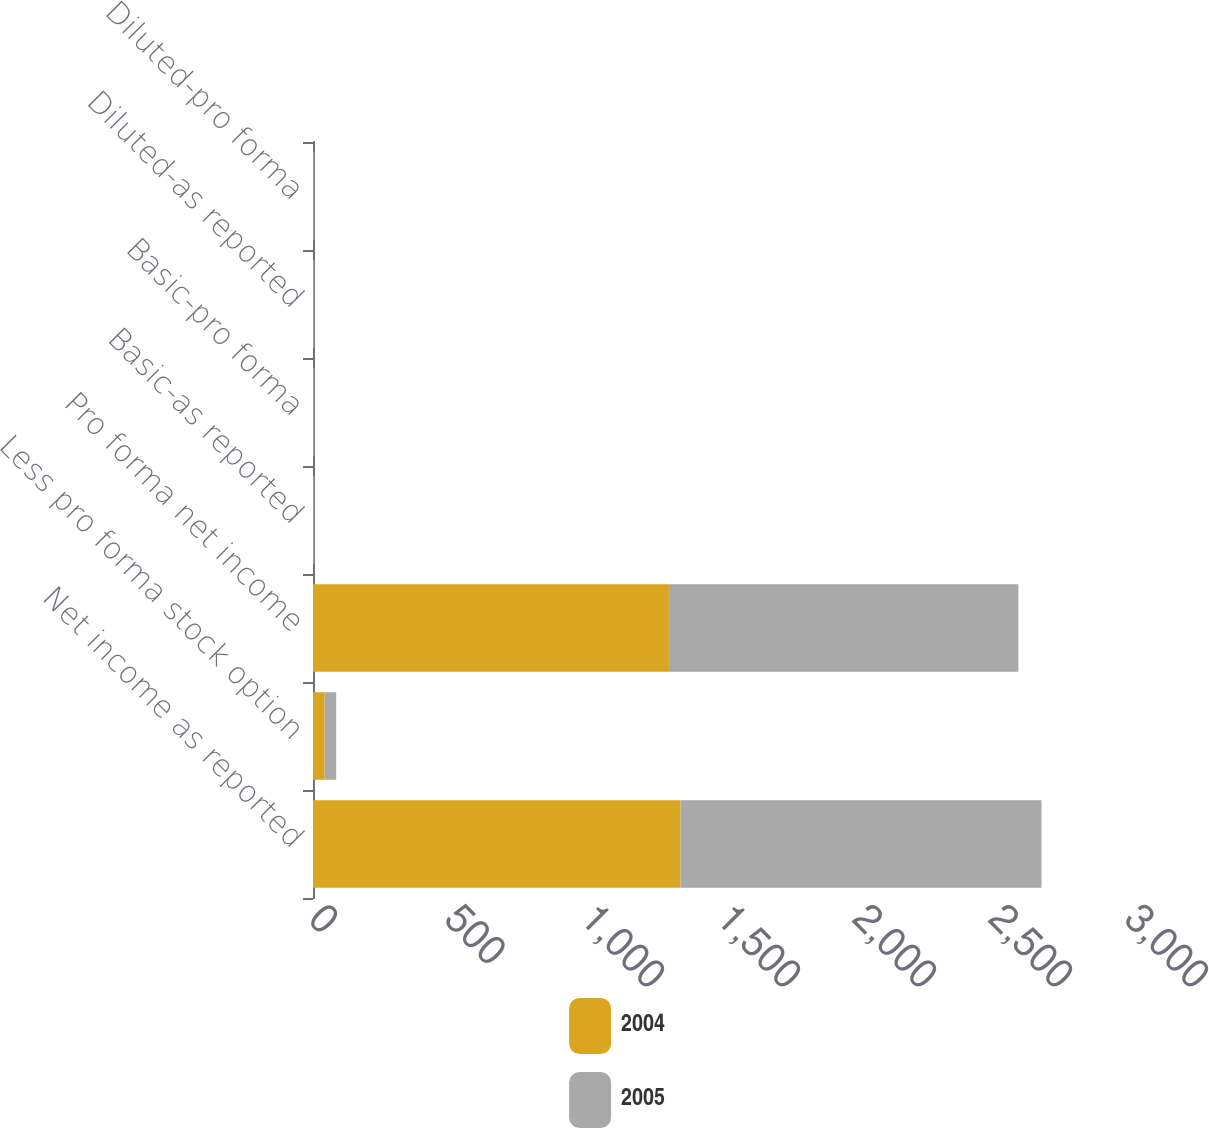Convert chart. <chart><loc_0><loc_0><loc_500><loc_500><stacked_bar_chart><ecel><fcel>Net income as reported<fcel>Less pro forma stock option<fcel>Pro forma net income<fcel>Basic-as reported<fcel>Basic-pro forma<fcel>Diluted-as reported<fcel>Diluted-pro forma<nl><fcel>2004<fcel>1351.4<fcel>42.9<fcel>1308.5<fcel>2.54<fcel>2.46<fcel>2.43<fcel>2.35<nl><fcel>2005<fcel>1327.1<fcel>42.3<fcel>1284.8<fcel>2.45<fcel>2.37<fcel>2.33<fcel>2.26<nl></chart> 